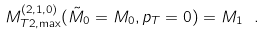<formula> <loc_0><loc_0><loc_500><loc_500>M _ { T 2 , \max } ^ { ( 2 , 1 , 0 ) } ( \tilde { M } _ { 0 } = M _ { 0 } , p _ { T } = 0 ) = M _ { 1 } \ .</formula> 